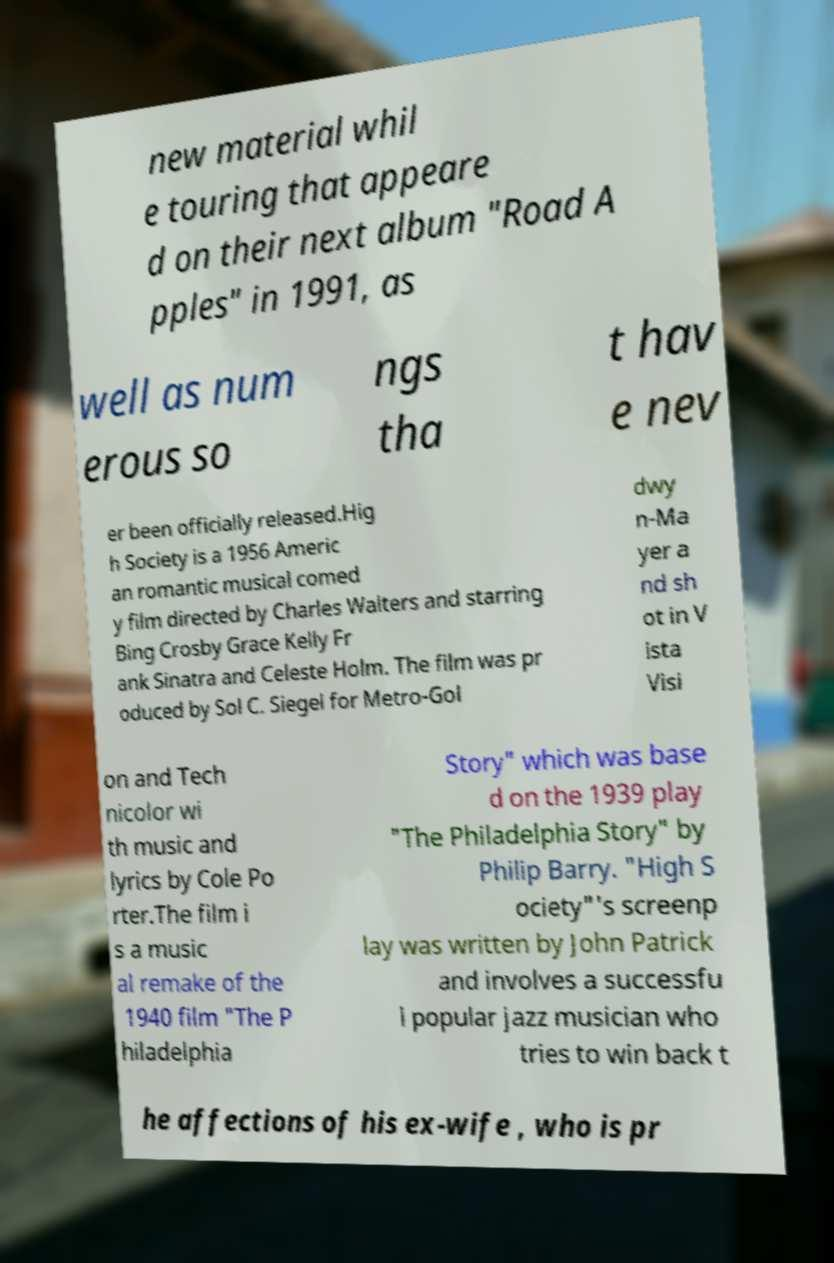There's text embedded in this image that I need extracted. Can you transcribe it verbatim? new material whil e touring that appeare d on their next album "Road A pples" in 1991, as well as num erous so ngs tha t hav e nev er been officially released.Hig h Society is a 1956 Americ an romantic musical comed y film directed by Charles Walters and starring Bing Crosby Grace Kelly Fr ank Sinatra and Celeste Holm. The film was pr oduced by Sol C. Siegel for Metro-Gol dwy n-Ma yer a nd sh ot in V ista Visi on and Tech nicolor wi th music and lyrics by Cole Po rter.The film i s a music al remake of the 1940 film "The P hiladelphia Story" which was base d on the 1939 play "The Philadelphia Story" by Philip Barry. "High S ociety"'s screenp lay was written by John Patrick and involves a successfu l popular jazz musician who tries to win back t he affections of his ex-wife , who is pr 